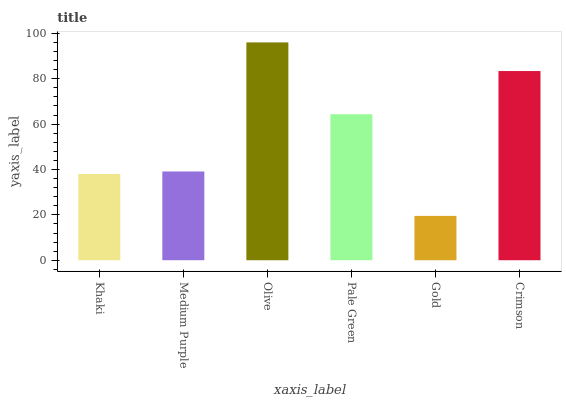Is Gold the minimum?
Answer yes or no. Yes. Is Olive the maximum?
Answer yes or no. Yes. Is Medium Purple the minimum?
Answer yes or no. No. Is Medium Purple the maximum?
Answer yes or no. No. Is Medium Purple greater than Khaki?
Answer yes or no. Yes. Is Khaki less than Medium Purple?
Answer yes or no. Yes. Is Khaki greater than Medium Purple?
Answer yes or no. No. Is Medium Purple less than Khaki?
Answer yes or no. No. Is Pale Green the high median?
Answer yes or no. Yes. Is Medium Purple the low median?
Answer yes or no. Yes. Is Olive the high median?
Answer yes or no. No. Is Gold the low median?
Answer yes or no. No. 